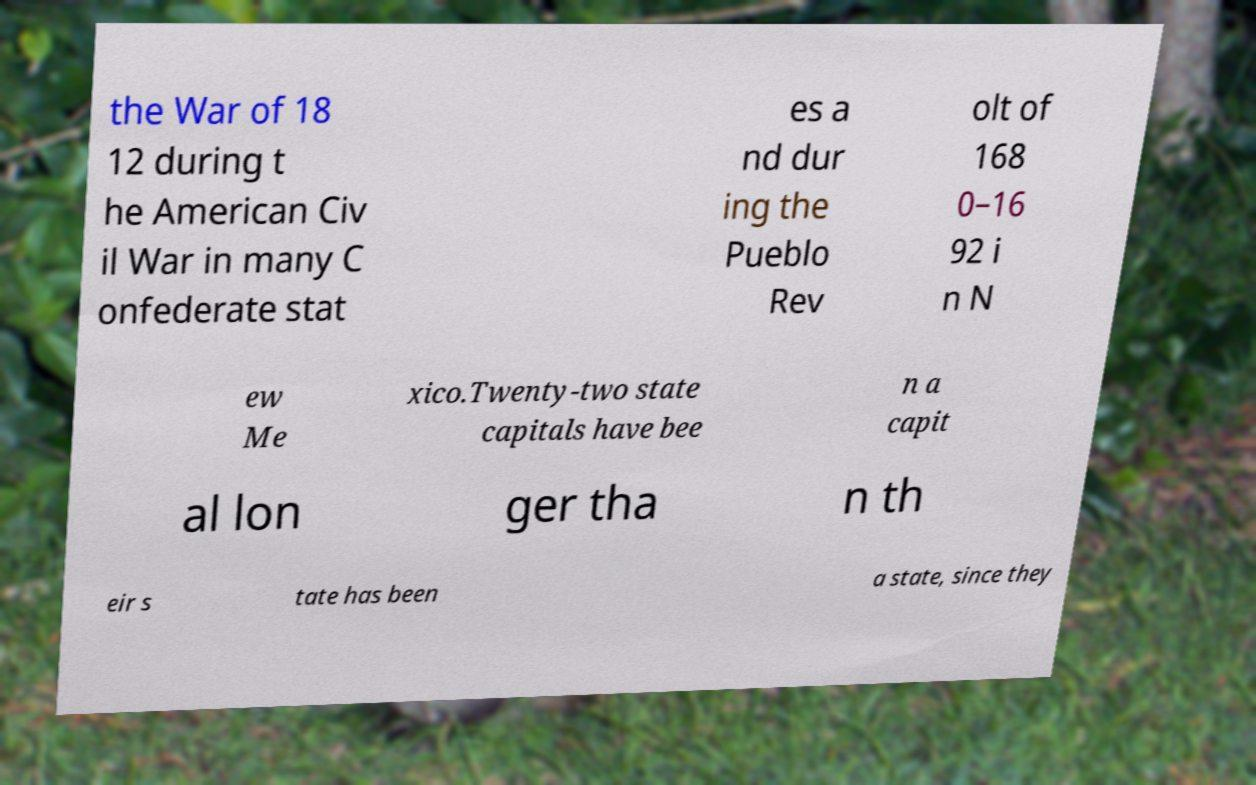I need the written content from this picture converted into text. Can you do that? the War of 18 12 during t he American Civ il War in many C onfederate stat es a nd dur ing the Pueblo Rev olt of 168 0–16 92 i n N ew Me xico.Twenty-two state capitals have bee n a capit al lon ger tha n th eir s tate has been a state, since they 